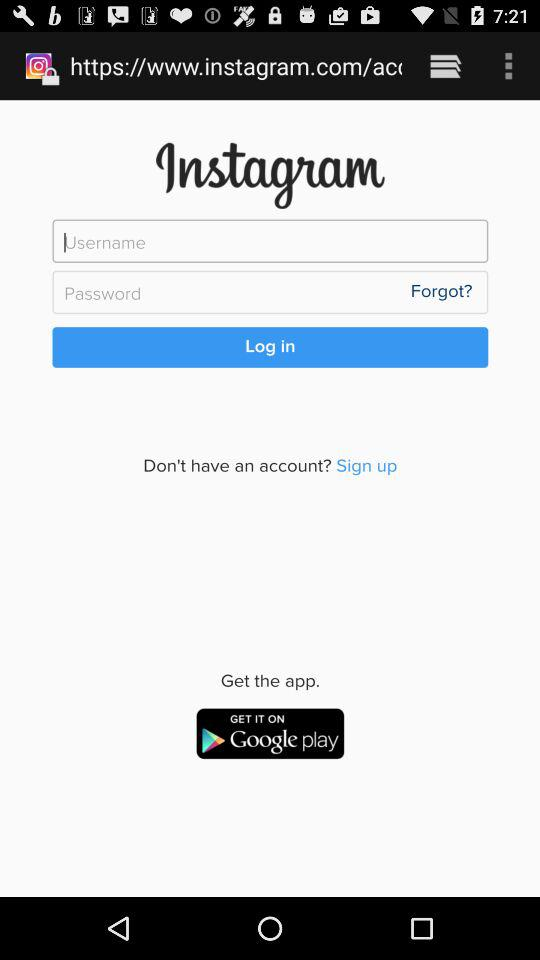What is the name of the application? The name of the application is "Instagram". 